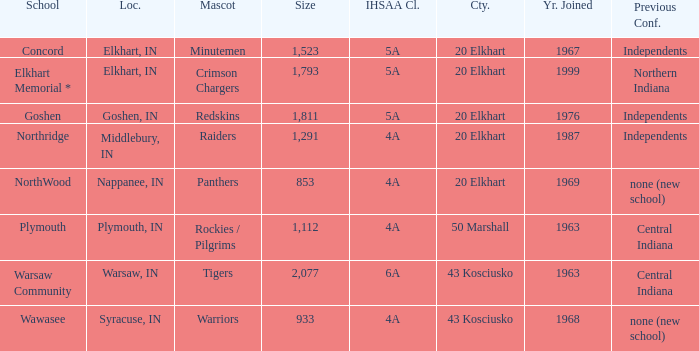What is the size of the team that was previously from Central Indiana conference, and is in IHSSA Class 4a? 1112.0. Would you be able to parse every entry in this table? {'header': ['School', 'Loc.', 'Mascot', 'Size', 'IHSAA Cl.', 'Cty.', 'Yr. Joined', 'Previous Conf.'], 'rows': [['Concord', 'Elkhart, IN', 'Minutemen', '1,523', '5A', '20 Elkhart', '1967', 'Independents'], ['Elkhart Memorial *', 'Elkhart, IN', 'Crimson Chargers', '1,793', '5A', '20 Elkhart', '1999', 'Northern Indiana'], ['Goshen', 'Goshen, IN', 'Redskins', '1,811', '5A', '20 Elkhart', '1976', 'Independents'], ['Northridge', 'Middlebury, IN', 'Raiders', '1,291', '4A', '20 Elkhart', '1987', 'Independents'], ['NorthWood', 'Nappanee, IN', 'Panthers', '853', '4A', '20 Elkhart', '1969', 'none (new school)'], ['Plymouth', 'Plymouth, IN', 'Rockies / Pilgrims', '1,112', '4A', '50 Marshall', '1963', 'Central Indiana'], ['Warsaw Community', 'Warsaw, IN', 'Tigers', '2,077', '6A', '43 Kosciusko', '1963', 'Central Indiana'], ['Wawasee', 'Syracuse, IN', 'Warriors', '933', '4A', '43 Kosciusko', '1968', 'none (new school)']]} 